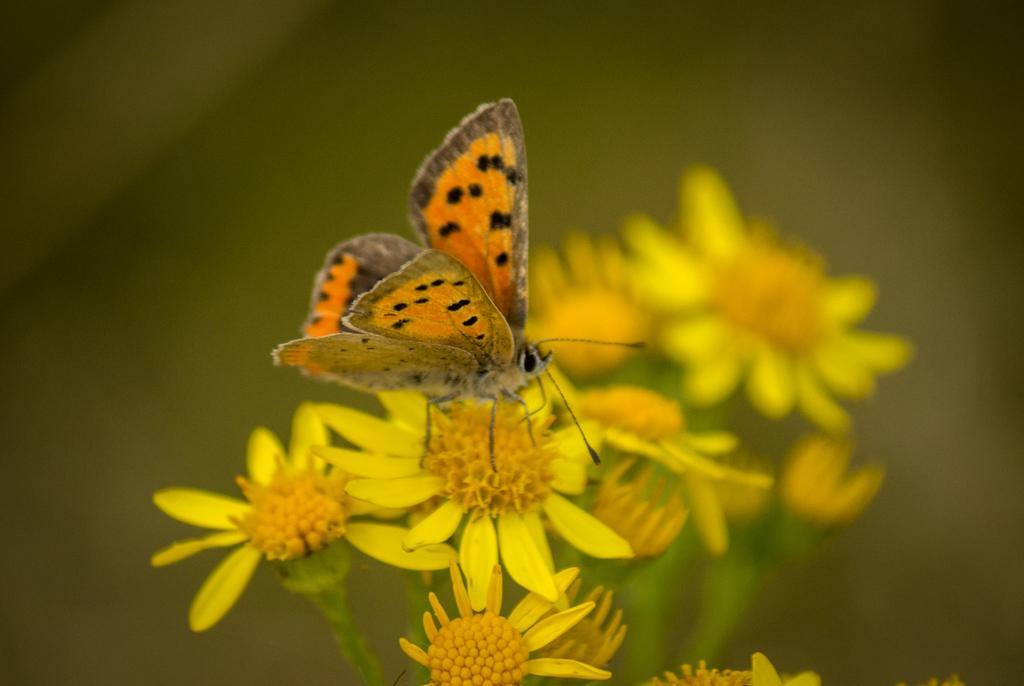How would you summarize this image in a sentence or two? In this image we can see a butterfly and some flowers. In the background of the image there is a blur background. 